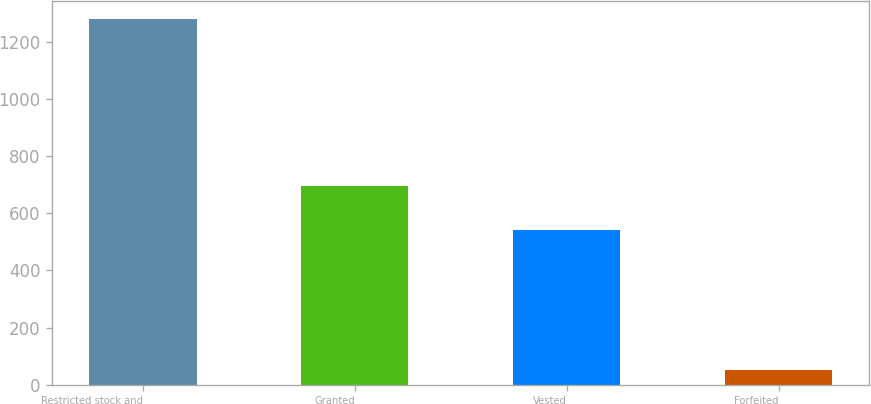Convert chart to OTSL. <chart><loc_0><loc_0><loc_500><loc_500><bar_chart><fcel>Restricted stock and<fcel>Granted<fcel>Vested<fcel>Forfeited<nl><fcel>1281.3<fcel>696<fcel>543<fcel>50<nl></chart> 